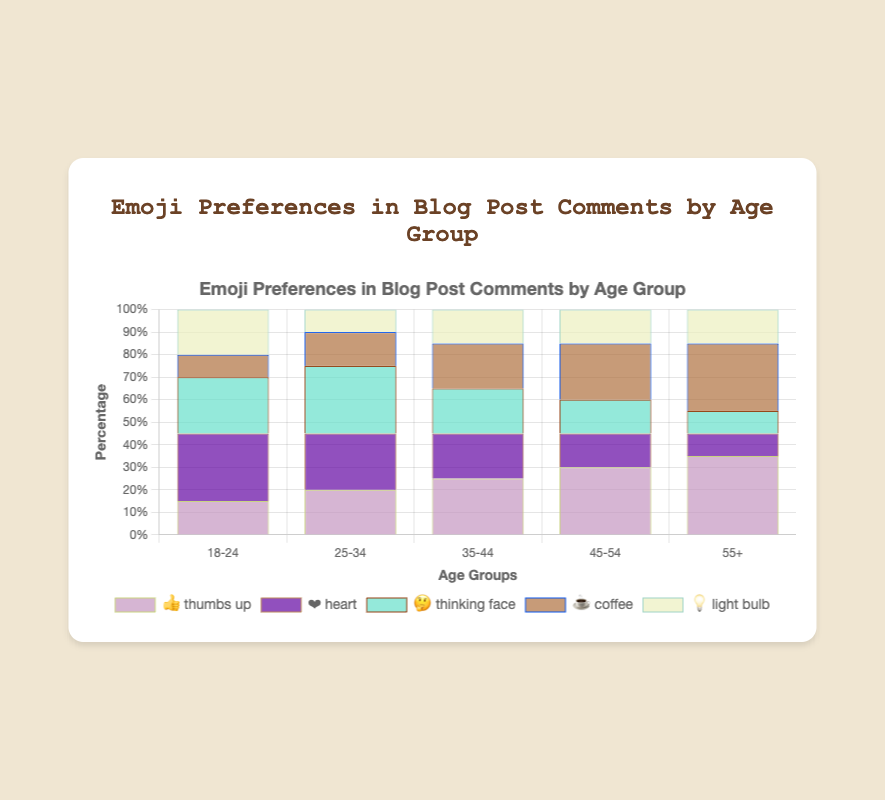What is the title of the figure? The title is located at the top of the figure and reads "Emoji Preferences in Blog Post Comments by Age Group".
Answer: Emoji Preferences in Blog Post Comments by Age Group Which age group prefers the "thumbs up" emoji the most? By looking at the bars for the "thumbs up" emoji across the different age groups, the tallest bar is for the age group "55+".
Answer: 55+ How does the preference for the "heart" emoji change as the age group increases? Observing the "heart" emoji bars from left to right (younger to older age groups), the height of the bars decreases, indicating a declining preference.
Answer: Decreases What is the sum of percentages for the "light bulb" emoji across all age groups? Adding up the percentages for the "light bulb" emoji: 20% (18-24) + 10% (25-34) + 15% (35-44) + 15% (45-54) + 15% (55+) = 75%.
Answer: 75% Which emoji has the most varied preference percentages across age groups? By comparing the range of percentages across all age groups for each emoji, the "thumbs up" emoji shows the most variation, going from 15% (18-24) to 35% (55+).
Answer: Thumbs up For the "coffee" emoji, which age group has the second-highest preference? Sorting the preferences for the "coffee" emoji in descending order, the age group "45-54" has the second-highest percentage at 25%.
Answer: 45-54 What is the average preference for the "thinking face" emoji? Adding the percentages for the "thinking face" emoji and dividing by the number of age groups: (25 + 30 + 20 + 15 + 10) / 5 = 100 / 5 = 20%.
Answer: 20% Do any age groups have equal percentages for more than one emoji? Checking each age group, we see that for "45-54", both the "thinking face" and "light bulb" emojis are at 15%. Similarly, for "55+", the "thinking face", "heart", and "light bulb" emojis are all at 10%.
Answer: Yes, 45-54 and 55+ Which emoji has the least preference in the age group "18-24"? By observing the bars for the age group "18-24", the shortest bar is for the "coffee" emoji at 10%.
Answer: Coffee 